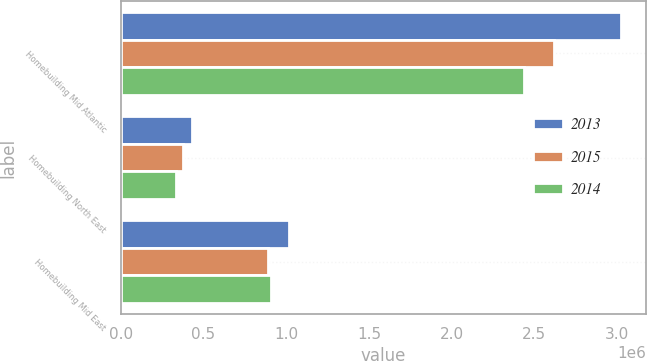Convert chart. <chart><loc_0><loc_0><loc_500><loc_500><stacked_bar_chart><ecel><fcel>Homebuilding Mid Atlantic<fcel>Homebuilding North East<fcel>Homebuilding Mid East<nl><fcel>2013<fcel>3.02279e+06<fcel>432145<fcel>1.01492e+06<nl><fcel>2015<fcel>2.61711e+06<fcel>376862<fcel>892513<nl><fcel>2014<fcel>2.43939e+06<fcel>332681<fcel>908198<nl></chart> 